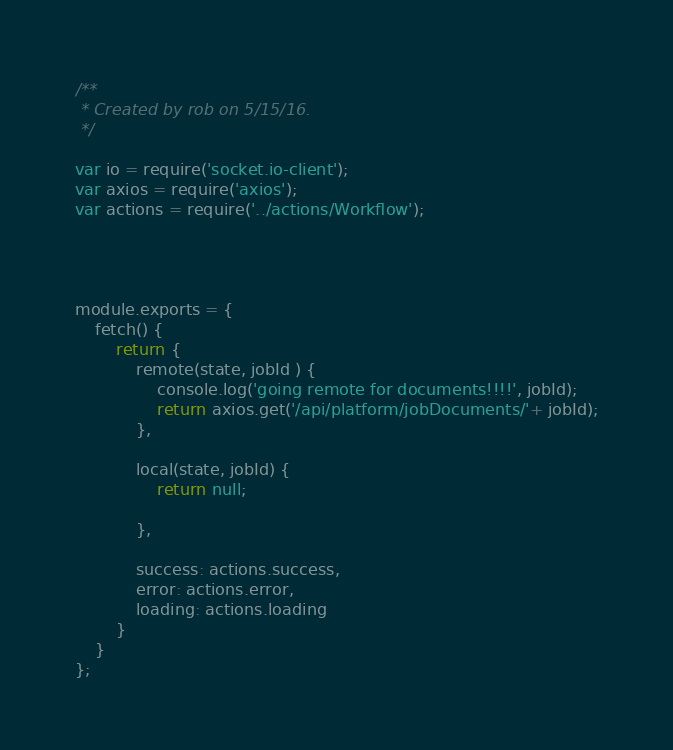<code> <loc_0><loc_0><loc_500><loc_500><_JavaScript_>/**
 * Created by rob on 5/15/16.
 */

var io = require('socket.io-client');
var axios = require('axios');
var actions = require('../actions/Workflow');




module.exports = {
    fetch() {
        return {
            remote(state, jobId ) {
                console.log('going remote for documents!!!!', jobId);
                return axios.get('/api/platform/jobDocuments/'+ jobId);
            },

            local(state, jobId) {
                return null;

            },

            success: actions.success,
            error: actions.error,
            loading: actions.loading
        }
    }
};

</code> 